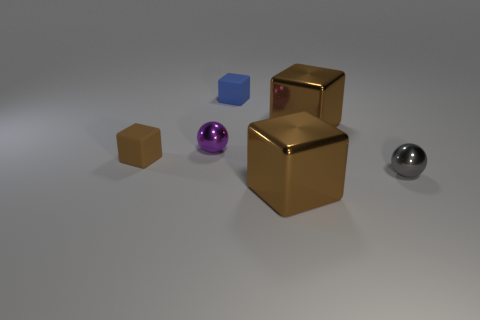The purple thing that is the same size as the brown matte thing is what shape?
Give a very brief answer. Sphere. Does the brown metallic block behind the tiny brown thing have the same size as the metallic cube that is in front of the tiny brown cube?
Give a very brief answer. Yes. How many large green shiny cylinders are there?
Give a very brief answer. 0. There is a brown object that is on the right side of the brown shiny block in front of the large cube behind the gray object; what is its size?
Give a very brief answer. Large. What number of purple shiny things are to the left of the gray sphere?
Your answer should be compact. 1. Are there an equal number of balls that are behind the small gray ball and small red rubber cylinders?
Offer a very short reply. No. What number of things are either metallic cubes or tiny purple rubber spheres?
Keep it short and to the point. 2. There is a brown metallic object behind the large brown object that is in front of the tiny purple metal ball; what is its shape?
Offer a terse response. Cube. There is another object that is made of the same material as the tiny blue thing; what is its shape?
Offer a terse response. Cube. How big is the metallic block in front of the shiny ball that is in front of the tiny brown thing?
Offer a very short reply. Large. 